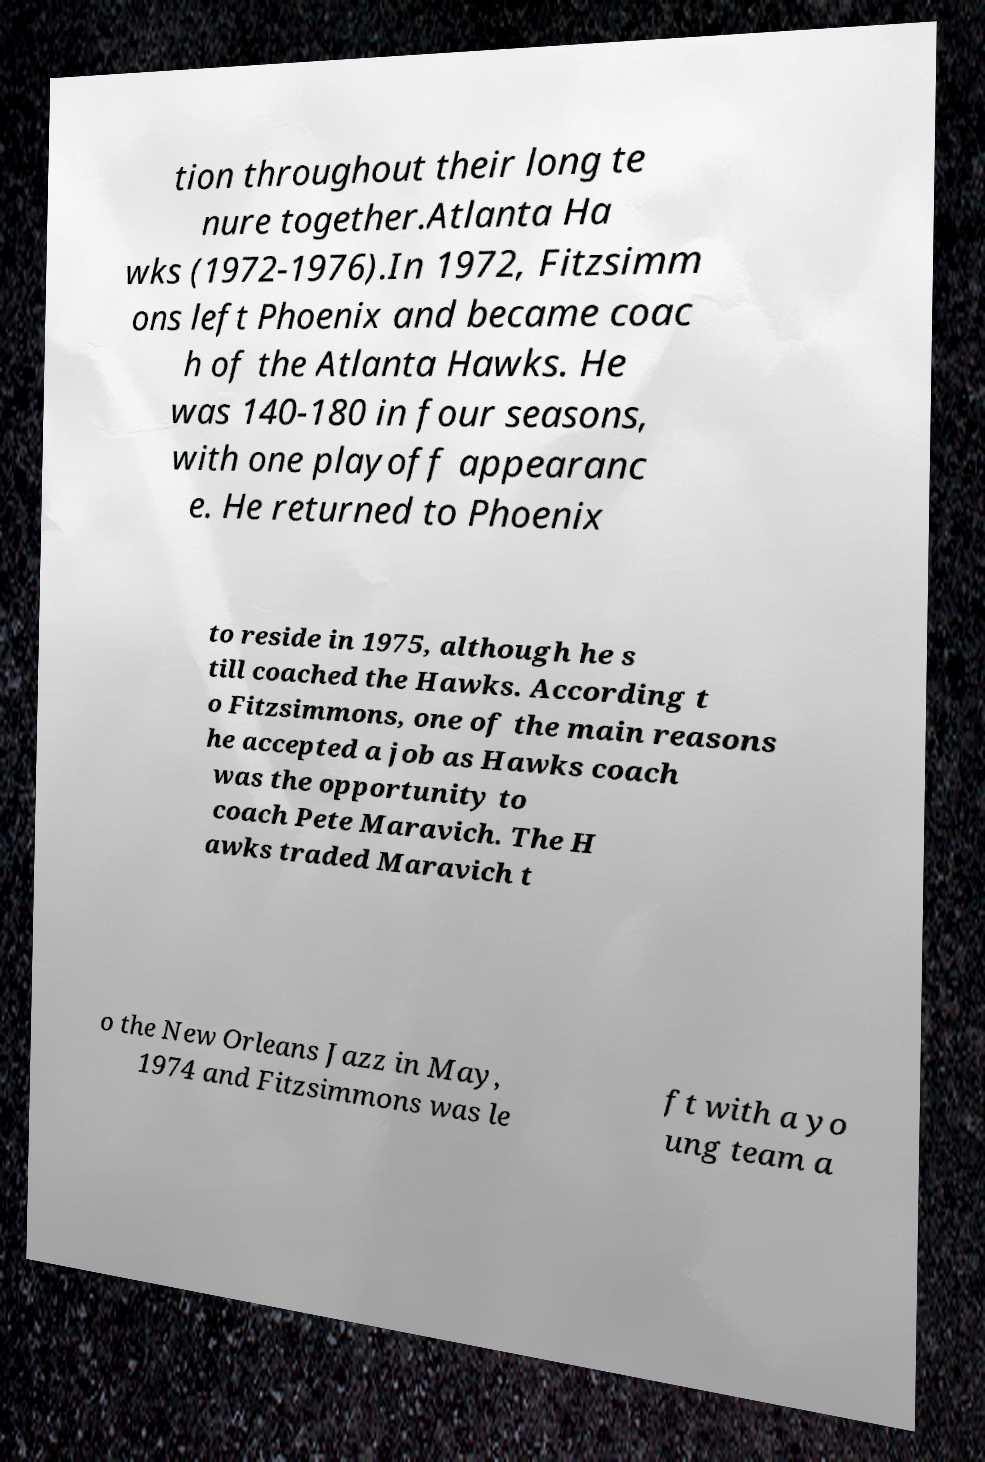Could you extract and type out the text from this image? tion throughout their long te nure together.Atlanta Ha wks (1972-1976).In 1972, Fitzsimm ons left Phoenix and became coac h of the Atlanta Hawks. He was 140-180 in four seasons, with one playoff appearanc e. He returned to Phoenix to reside in 1975, although he s till coached the Hawks. According t o Fitzsimmons, one of the main reasons he accepted a job as Hawks coach was the opportunity to coach Pete Maravich. The H awks traded Maravich t o the New Orleans Jazz in May, 1974 and Fitzsimmons was le ft with a yo ung team a 